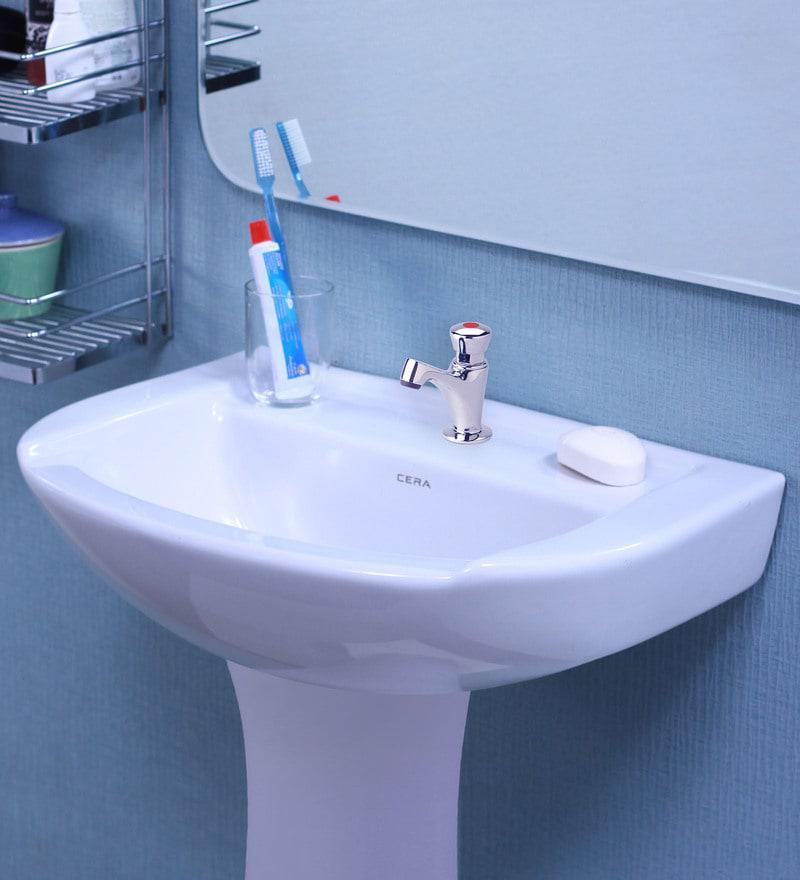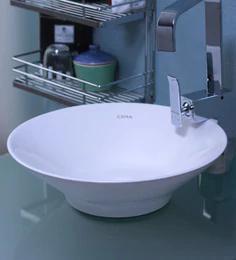The first image is the image on the left, the second image is the image on the right. Assess this claim about the two images: "Two white sinks have center faucets and are mounted so the outer sink is shown.". Correct or not? Answer yes or no. Yes. 